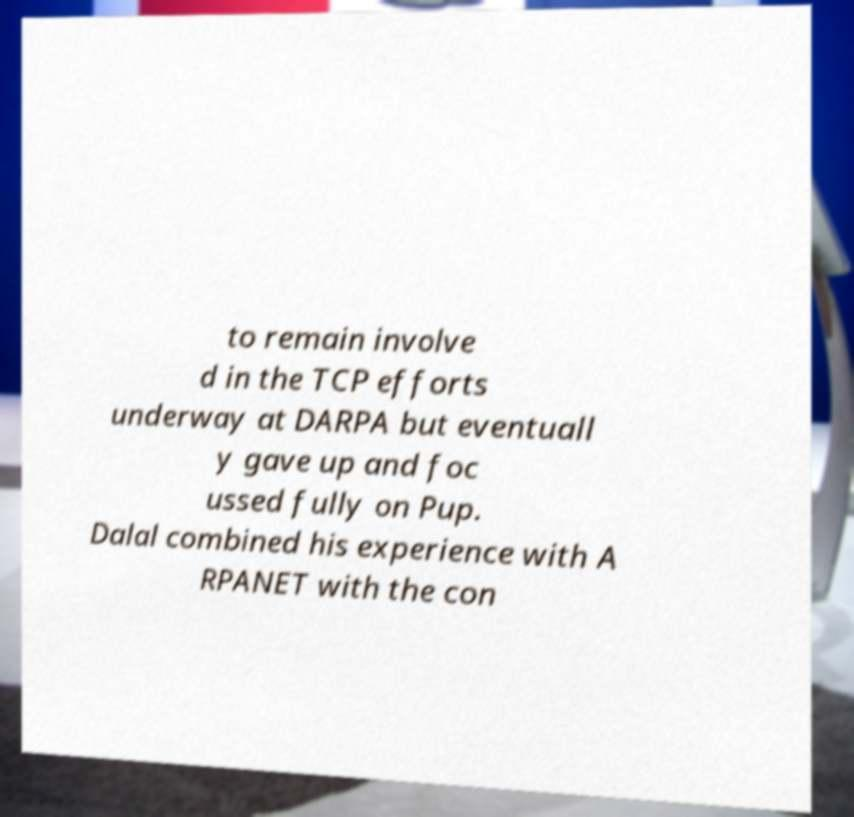What messages or text are displayed in this image? I need them in a readable, typed format. to remain involve d in the TCP efforts underway at DARPA but eventuall y gave up and foc ussed fully on Pup. Dalal combined his experience with A RPANET with the con 